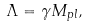Convert formula to latex. <formula><loc_0><loc_0><loc_500><loc_500>\Lambda = \gamma M _ { p l } ,</formula> 